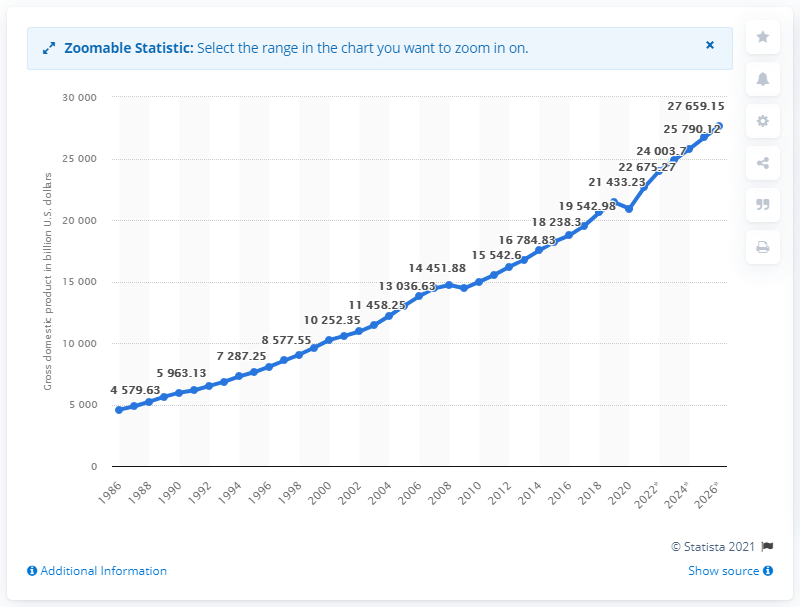Mention a couple of crucial points in this snapshot. In 2026, the highest point was recorded. The highest point and the lowest point in terms of dollars are $23,079.52. In 2020, the gross domestic product of the United States was 209,32.75 trillion dollars. 